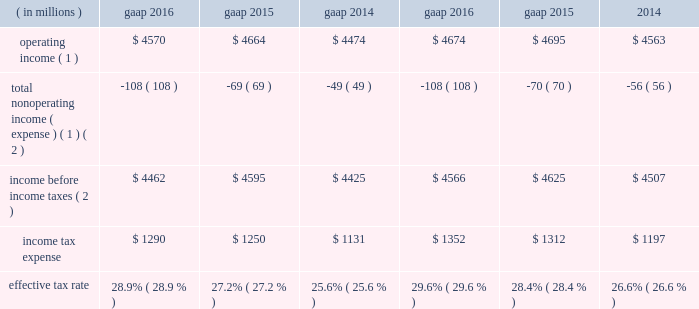2016 compared with 2015 net gains on investments of $ 57 million in 2016 decreased $ 52 million from 2015 due to lower net gains in 2016 .
Net gains on investments in 2015 included a $ 40 million gain related to the bkca acquisition and a $ 35 million unrealized gain on a private equity investment .
Interest and dividend income increased $ 14 million from 2015 primarily due to higher dividend income in 2016 .
2015 compared with 2014 net gains on investments of $ 109 million in 2015 decreased $ 45 million from 2014 due to lower net gains in 2015 .
Net gains on investments in 2015 included a $ 40 million gain related to the bkca acquisition and a $ 35 million unrealized gain on a private equity investment .
Net gains on investments in 2014 included the positive impact of the monetization of a nonstrategic , opportunistic private equity investment .
Interest expense decreased $ 28 million from 2014 primarily due to repayments of long-term borrowings in the fourth quarter of 2014 .
Income tax expense .
( 1 ) see non-gaap financial measures for further information on and reconciliation of as adjusted items .
( 2 ) net of net income ( loss ) attributable to nci .
The company 2019s tax rate is affected by tax rates in foreign jurisdictions and the relative amount of income earned in those jurisdictions , which the company expects to be fairly consistent in the near term .
The significant foreign jurisdictions that have lower statutory tax rates than the u.s .
Federal statutory rate of 35% ( 35 % ) include the united kingdom , channel islands , ireland and canada .
U.s .
Income taxes were not provided for certain undistributed foreign earnings intended to be indefinitely reinvested outside the united states .
2016 .
Income tax expense ( gaap ) reflected : 2022 a net noncash benefit of $ 30 million , primarily associated with the revaluation of certain deferred income tax liabilities ; and 2022 a benefit from $ 65 million of nonrecurring items , including the resolution of certain outstanding tax matters .
The as adjusted effective tax rate of 29.6% ( 29.6 % ) for 2016 excluded the net noncash benefit of $ 30 million mentioned above , as it will not have a cash flow impact and to ensure comparability among periods presented .
2015 .
Income tax expense ( gaap ) reflected : 2022 a net noncash benefit of $ 54 million , primarily associated with the revaluation of certain deferred income tax liabilities ; and 2022 a benefit from $ 75 million of nonrecurring items , primarily due to the realization of losses from changes in the company 2019s organizational tax structure and the resolution of certain outstanding tax matters .
The as adjusted effective tax rate of 28.4% ( 28.4 % ) for 2015 excluded the net noncash benefit of $ 54 million mentioned above , as it will not have a cash flow impact and to ensure comparability among periods presented .
2014 .
Income tax expense ( gaap ) reflected : 2022 a $ 94 million tax benefit , primarily due to the resolution of certain outstanding tax matters related to the acquisition of bgi , including the previously mentioned $ 50 million tax benefit ( see executive summary for more information ) ; 2022 a $ 73 million net tax benefit related to several favorable nonrecurring items ; and 2022 a net noncash benefit of $ 9 million associated with the revaluation of deferred income tax liabilities .
The as adjusted effective tax rate of 26.6% ( 26.6 % ) for 2014 excluded the $ 9 million net noncash benefit as it will not have a cash flow impact and to ensure comparability among periods presented and the $ 50 million tax benefit mentioned above .
The $ 50 million general and administrative expense and $ 50 million tax benefit have been excluded from as adjusted results as there is no impact on blackrock 2019s book value .
Balance sheet overview as adjusted balance sheet the following table presents a reconciliation of the consolidated statement of financial condition presented on a gaap basis to the consolidated statement of financial condition , excluding the impact of separate account assets and separate account collateral held under securities lending agreements ( directly related to lending separate account securities ) and separate account liabilities and separate account collateral liabilities under securities lending agreements and consolidated sponsored investment funds , including consolidated vies .
The company presents the as adjusted balance sheet as additional information to enable investors to exclude certain .
What is the net income in 2016? 
Rationale: operating income - income tax expense = net income
Computations: (4570 - 1290)
Answer: 3280.0. 